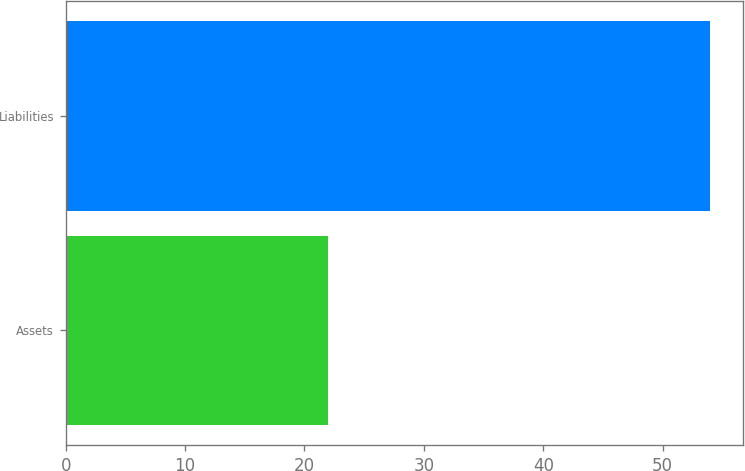<chart> <loc_0><loc_0><loc_500><loc_500><bar_chart><fcel>Assets<fcel>Liabilities<nl><fcel>22<fcel>54<nl></chart> 